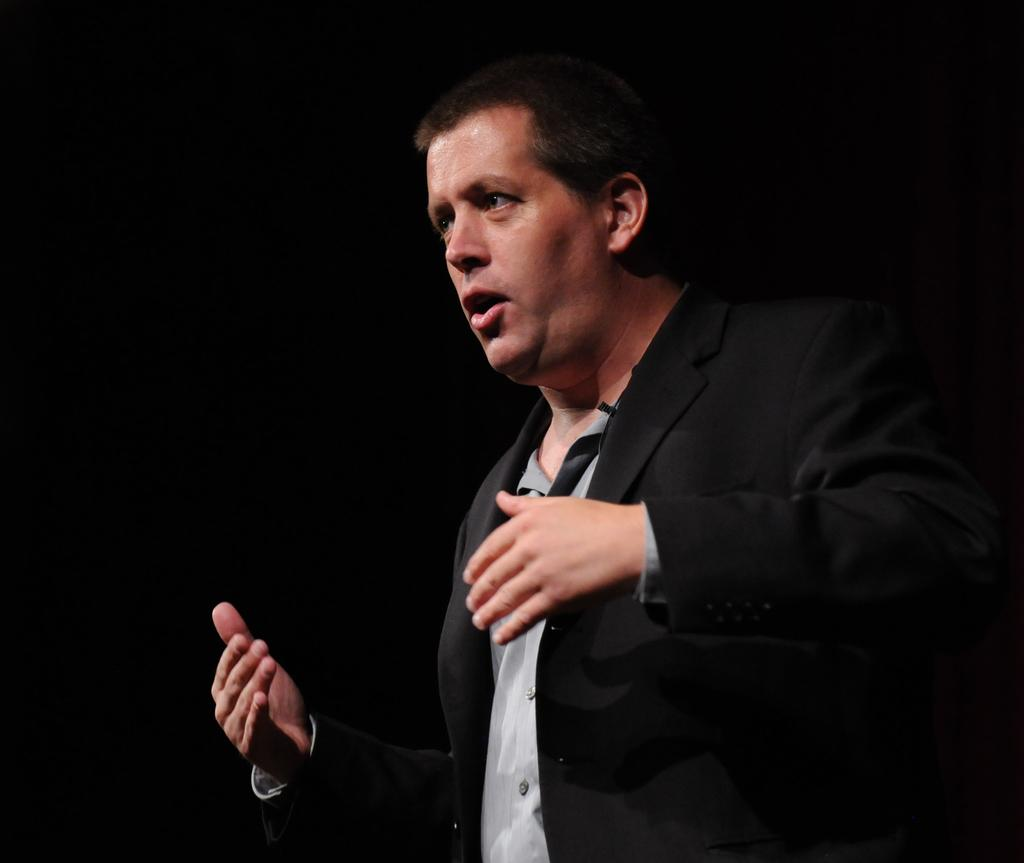Who is the main subject in the image? There is a man in the image. What is the man doing in the image? The man is standing and giving a speech. What is the man wearing on his upper body? The man is wearing a black color blazer and a white shirt. What is the title of the hall where the man is giving the speech? There is no information about a hall or a title in the image. 